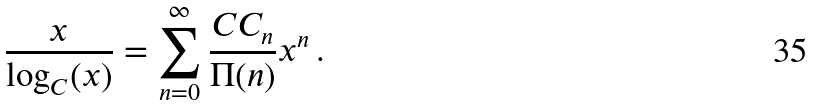<formula> <loc_0><loc_0><loc_500><loc_500>\frac { x } { \log _ { C } ( x ) } = \sum _ { n = 0 } ^ { \infty } \frac { C C _ { n } } { \Pi ( n ) } x ^ { n } \, .</formula> 